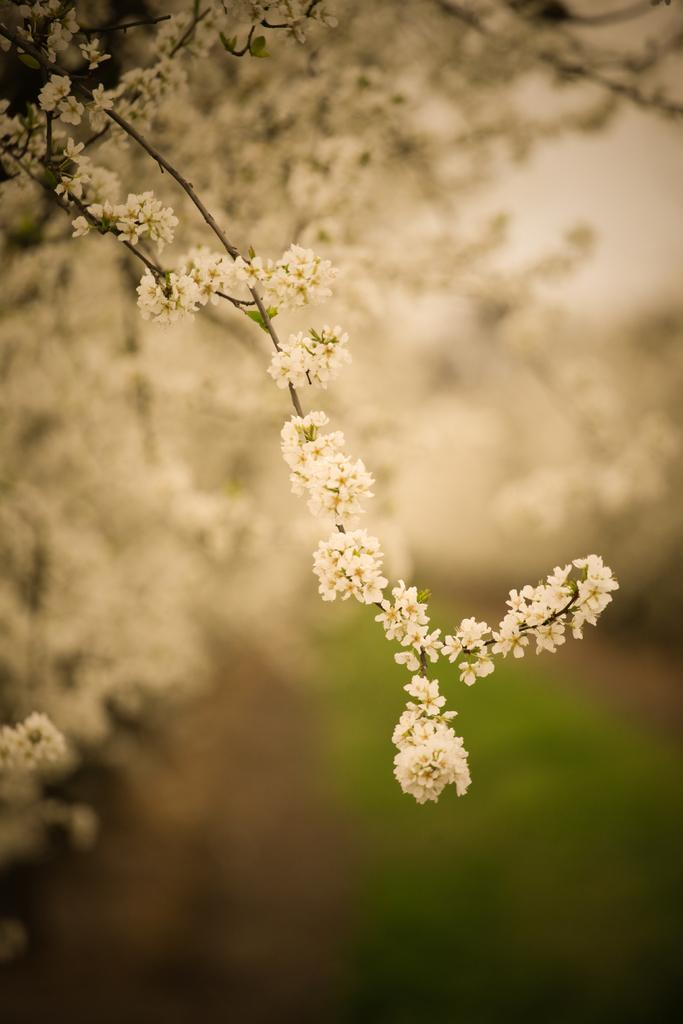What type of plants can be seen in the image? There are flowers in the image. What other natural elements are present in the image? There is grass in the image. Can you describe the background of the image? The background of the image is blurry. What type of education can be seen in the image? There is no reference to education in the image; it features flowers and grass. What type of clover is present in the image? There is no clover present in the image; it features flowers and grass. 